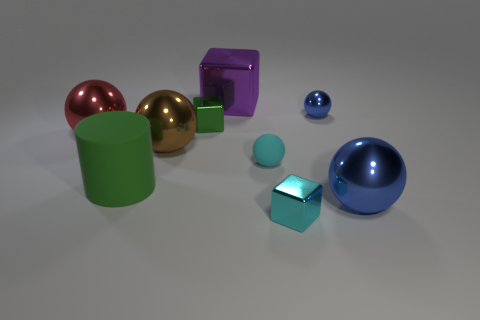Subtract all tiny green metallic blocks. How many blocks are left? 2 Subtract all balls. How many objects are left? 4 Add 1 large matte cylinders. How many objects exist? 10 Subtract all red balls. How many brown cubes are left? 0 Subtract all small things. Subtract all small purple shiny blocks. How many objects are left? 5 Add 2 big metallic cubes. How many big metallic cubes are left? 3 Add 7 cyan metal blocks. How many cyan metal blocks exist? 8 Subtract all green cubes. How many cubes are left? 2 Subtract 0 yellow balls. How many objects are left? 9 Subtract 2 cubes. How many cubes are left? 1 